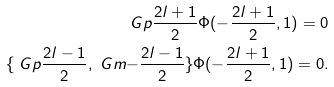<formula> <loc_0><loc_0><loc_500><loc_500>\ G p { \frac { 2 l + 1 } { 2 } } \Phi ( - \frac { 2 l + 1 } { 2 } , 1 ) = 0 \\ \{ \ G p { \frac { 2 l - 1 } { 2 } } , \ G m { - \frac { 2 l - 1 } { 2 } } \} \Phi ( - \frac { 2 l + 1 } { 2 } , 1 ) = 0 .</formula> 